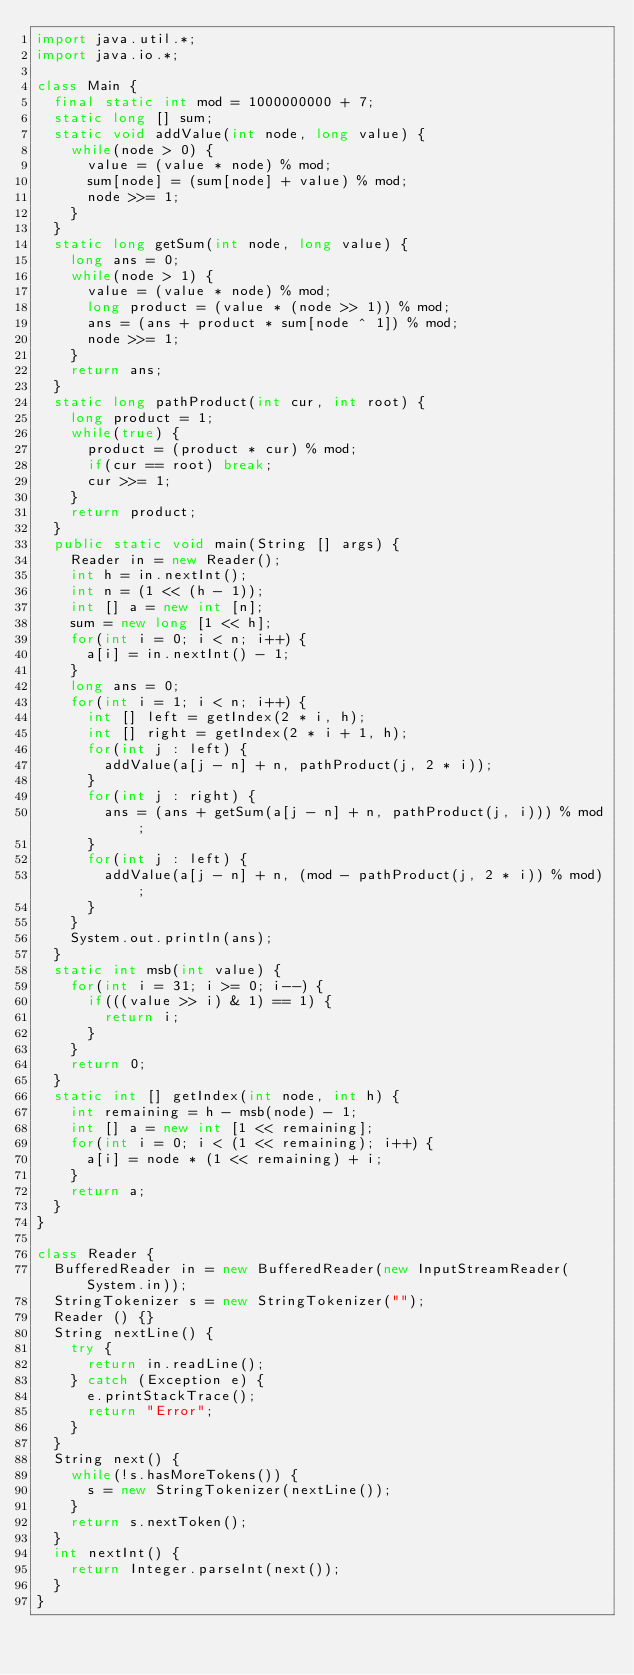Convert code to text. <code><loc_0><loc_0><loc_500><loc_500><_Java_>import java.util.*;
import java.io.*;

class Main {
  final static int mod = 1000000000 + 7;
  static long [] sum;
  static void addValue(int node, long value) {
    while(node > 0) {
      value = (value * node) % mod;
      sum[node] = (sum[node] + value) % mod;
      node >>= 1;
    }
  }
  static long getSum(int node, long value) {
    long ans = 0;
    while(node > 1) {
      value = (value * node) % mod;
      long product = (value * (node >> 1)) % mod;
      ans = (ans + product * sum[node ^ 1]) % mod;
      node >>= 1;
    }
    return ans;
  }
  static long pathProduct(int cur, int root) {
    long product = 1;
    while(true) {
      product = (product * cur) % mod;
      if(cur == root) break;
      cur >>= 1;
    }
    return product;
  }
  public static void main(String [] args) {
    Reader in = new Reader();
    int h = in.nextInt();
    int n = (1 << (h - 1));
    int [] a = new int [n];
    sum = new long [1 << h];
    for(int i = 0; i < n; i++) {
      a[i] = in.nextInt() - 1;
    }
    long ans = 0;
    for(int i = 1; i < n; i++) {
      int [] left = getIndex(2 * i, h);
      int [] right = getIndex(2 * i + 1, h);
      for(int j : left) {
        addValue(a[j - n] + n, pathProduct(j, 2 * i));  
      }
      for(int j : right) {
        ans = (ans + getSum(a[j - n] + n, pathProduct(j, i))) % mod; 
      }
      for(int j : left) {
        addValue(a[j - n] + n, (mod - pathProduct(j, 2 * i)) % mod);
      }
    }
    System.out.println(ans);
  }
  static int msb(int value) {
    for(int i = 31; i >= 0; i--) {
      if(((value >> i) & 1) == 1) {
        return i;
      }
    }
    return 0;
  }
  static int [] getIndex(int node, int h) {
    int remaining = h - msb(node) - 1;
    int [] a = new int [1 << remaining];
    for(int i = 0; i < (1 << remaining); i++) {
      a[i] = node * (1 << remaining) + i;
    }
    return a;
  }
}

class Reader {
  BufferedReader in = new BufferedReader(new InputStreamReader(System.in));
  StringTokenizer s = new StringTokenizer("");
  Reader () {}
  String nextLine() {
    try {
      return in.readLine();
    } catch (Exception e) {
      e.printStackTrace();
      return "Error";
    }
  }
  String next() {
    while(!s.hasMoreTokens()) {
      s = new StringTokenizer(nextLine());
    }
    return s.nextToken();
  }
  int nextInt() {
    return Integer.parseInt(next());
  }
}

</code> 